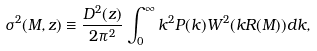<formula> <loc_0><loc_0><loc_500><loc_500>\sigma ^ { 2 } ( M , z ) \equiv \frac { D ^ { 2 } ( z ) } { 2 \pi ^ { 2 } } \int _ { 0 } ^ { \infty } { k ^ { 2 } P ( k ) W ^ { 2 } ( k R ( M ) ) d k } ,</formula> 